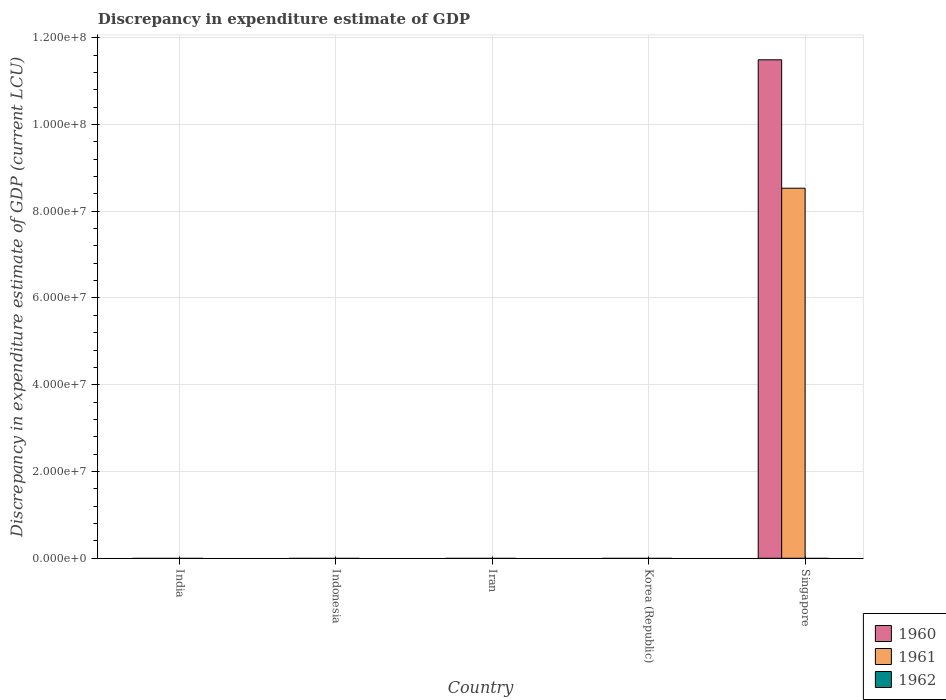How many different coloured bars are there?
Offer a terse response. 2. Are the number of bars on each tick of the X-axis equal?
Your answer should be very brief. No. How many bars are there on the 3rd tick from the left?
Provide a succinct answer. 0. How many bars are there on the 3rd tick from the right?
Your answer should be compact. 0. What is the label of the 5th group of bars from the left?
Your response must be concise. Singapore. In how many cases, is the number of bars for a given country not equal to the number of legend labels?
Your answer should be compact. 5. What is the discrepancy in expenditure estimate of GDP in 1961 in Iran?
Offer a very short reply. 0. Across all countries, what is the maximum discrepancy in expenditure estimate of GDP in 1961?
Ensure brevity in your answer.  8.53e+07. In which country was the discrepancy in expenditure estimate of GDP in 1960 maximum?
Offer a very short reply. Singapore. What is the total discrepancy in expenditure estimate of GDP in 1960 in the graph?
Ensure brevity in your answer.  1.15e+08. What is the difference between the discrepancy in expenditure estimate of GDP in 1960 in Indonesia and the discrepancy in expenditure estimate of GDP in 1961 in Korea (Republic)?
Offer a terse response. 0. What is the average discrepancy in expenditure estimate of GDP in 1961 per country?
Offer a terse response. 1.71e+07. What is the difference between the discrepancy in expenditure estimate of GDP of/in 1961 and discrepancy in expenditure estimate of GDP of/in 1960 in Singapore?
Provide a short and direct response. -2.96e+07. What is the difference between the highest and the lowest discrepancy in expenditure estimate of GDP in 1960?
Provide a succinct answer. 1.15e+08. In how many countries, is the discrepancy in expenditure estimate of GDP in 1961 greater than the average discrepancy in expenditure estimate of GDP in 1961 taken over all countries?
Offer a very short reply. 1. How many bars are there?
Give a very brief answer. 2. How many countries are there in the graph?
Offer a terse response. 5. What is the difference between two consecutive major ticks on the Y-axis?
Your answer should be compact. 2.00e+07. Are the values on the major ticks of Y-axis written in scientific E-notation?
Ensure brevity in your answer.  Yes. Does the graph contain any zero values?
Your answer should be very brief. Yes. Does the graph contain grids?
Offer a terse response. Yes. Where does the legend appear in the graph?
Offer a very short reply. Bottom right. How are the legend labels stacked?
Keep it short and to the point. Vertical. What is the title of the graph?
Keep it short and to the point. Discrepancy in expenditure estimate of GDP. What is the label or title of the X-axis?
Provide a succinct answer. Country. What is the label or title of the Y-axis?
Your response must be concise. Discrepancy in expenditure estimate of GDP (current LCU). What is the Discrepancy in expenditure estimate of GDP (current LCU) of 1961 in India?
Make the answer very short. 0. What is the Discrepancy in expenditure estimate of GDP (current LCU) of 1961 in Iran?
Offer a very short reply. 0. What is the Discrepancy in expenditure estimate of GDP (current LCU) of 1962 in Iran?
Offer a terse response. 0. What is the Discrepancy in expenditure estimate of GDP (current LCU) of 1961 in Korea (Republic)?
Give a very brief answer. 0. What is the Discrepancy in expenditure estimate of GDP (current LCU) of 1962 in Korea (Republic)?
Keep it short and to the point. 0. What is the Discrepancy in expenditure estimate of GDP (current LCU) in 1960 in Singapore?
Give a very brief answer. 1.15e+08. What is the Discrepancy in expenditure estimate of GDP (current LCU) of 1961 in Singapore?
Provide a short and direct response. 8.53e+07. Across all countries, what is the maximum Discrepancy in expenditure estimate of GDP (current LCU) in 1960?
Make the answer very short. 1.15e+08. Across all countries, what is the maximum Discrepancy in expenditure estimate of GDP (current LCU) of 1961?
Your answer should be compact. 8.53e+07. Across all countries, what is the minimum Discrepancy in expenditure estimate of GDP (current LCU) of 1960?
Provide a succinct answer. 0. What is the total Discrepancy in expenditure estimate of GDP (current LCU) in 1960 in the graph?
Your answer should be very brief. 1.15e+08. What is the total Discrepancy in expenditure estimate of GDP (current LCU) in 1961 in the graph?
Provide a succinct answer. 8.53e+07. What is the average Discrepancy in expenditure estimate of GDP (current LCU) in 1960 per country?
Ensure brevity in your answer.  2.30e+07. What is the average Discrepancy in expenditure estimate of GDP (current LCU) of 1961 per country?
Your response must be concise. 1.71e+07. What is the average Discrepancy in expenditure estimate of GDP (current LCU) in 1962 per country?
Make the answer very short. 0. What is the difference between the Discrepancy in expenditure estimate of GDP (current LCU) of 1960 and Discrepancy in expenditure estimate of GDP (current LCU) of 1961 in Singapore?
Offer a very short reply. 2.96e+07. What is the difference between the highest and the lowest Discrepancy in expenditure estimate of GDP (current LCU) of 1960?
Your answer should be very brief. 1.15e+08. What is the difference between the highest and the lowest Discrepancy in expenditure estimate of GDP (current LCU) in 1961?
Your response must be concise. 8.53e+07. 